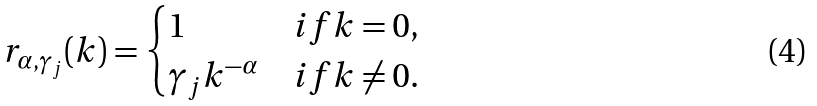<formula> <loc_0><loc_0><loc_500><loc_500>r _ { \alpha , \gamma _ { j } } ( k ) = \begin{cases} 1 & i f k = 0 , \\ \gamma _ { j } k ^ { - \alpha } & i f k \neq 0 . \end{cases}</formula> 